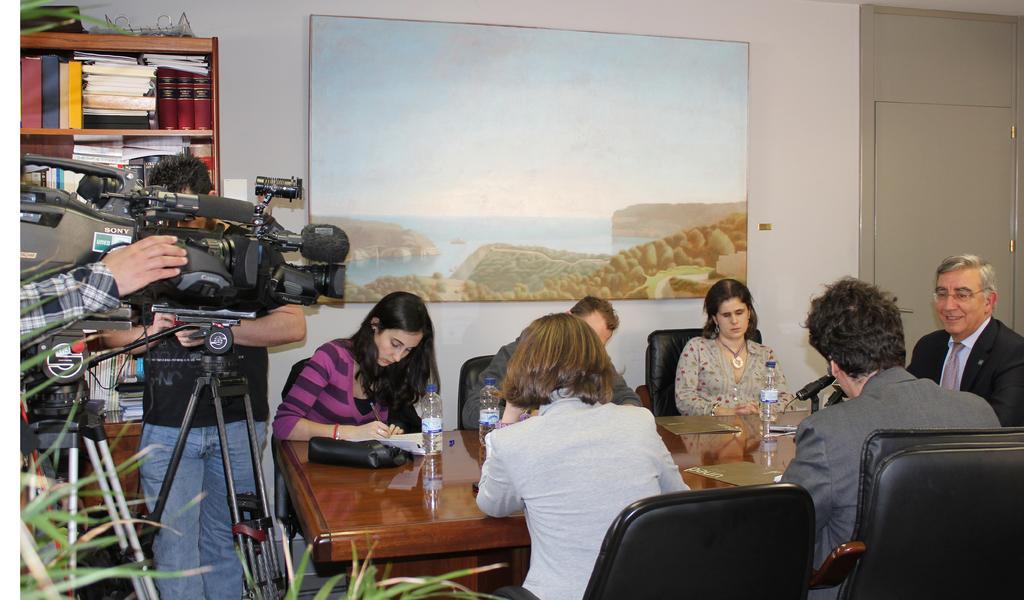How would you summarize this image in a sentence or two? In this image I can see people were few are standing and rest all are sitting on chairs. Here I can see a camera and few bottles on this table. In the background I can see a photo on this wall. 